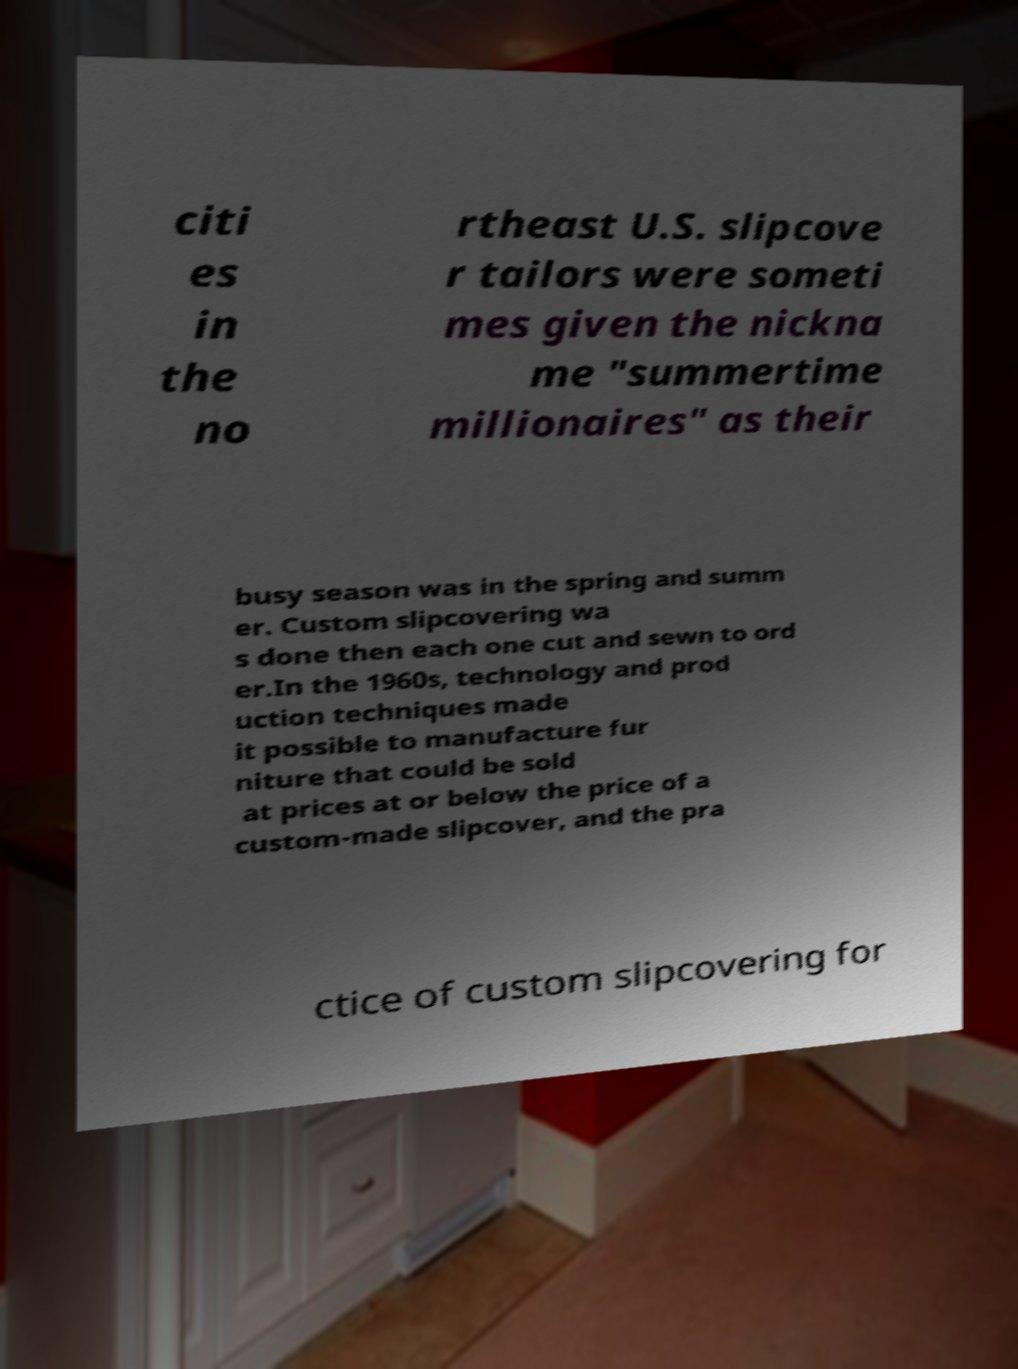There's text embedded in this image that I need extracted. Can you transcribe it verbatim? citi es in the no rtheast U.S. slipcove r tailors were someti mes given the nickna me "summertime millionaires" as their busy season was in the spring and summ er. Custom slipcovering wa s done then each one cut and sewn to ord er.In the 1960s, technology and prod uction techniques made it possible to manufacture fur niture that could be sold at prices at or below the price of a custom-made slipcover, and the pra ctice of custom slipcovering for 